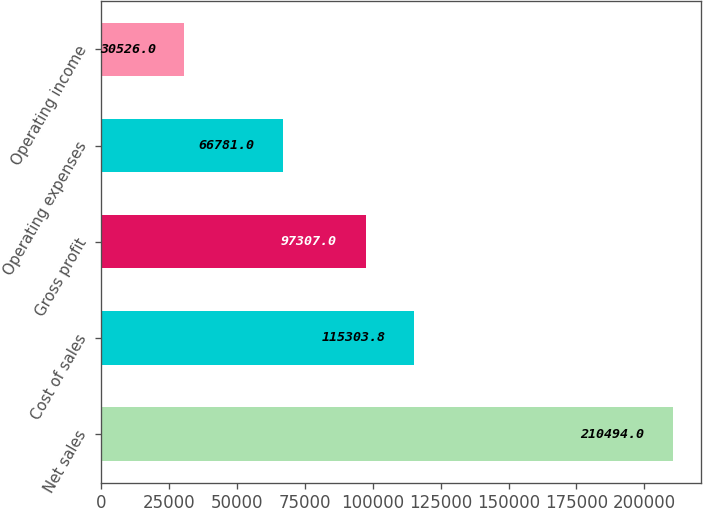<chart> <loc_0><loc_0><loc_500><loc_500><bar_chart><fcel>Net sales<fcel>Cost of sales<fcel>Gross profit<fcel>Operating expenses<fcel>Operating income<nl><fcel>210494<fcel>115304<fcel>97307<fcel>66781<fcel>30526<nl></chart> 